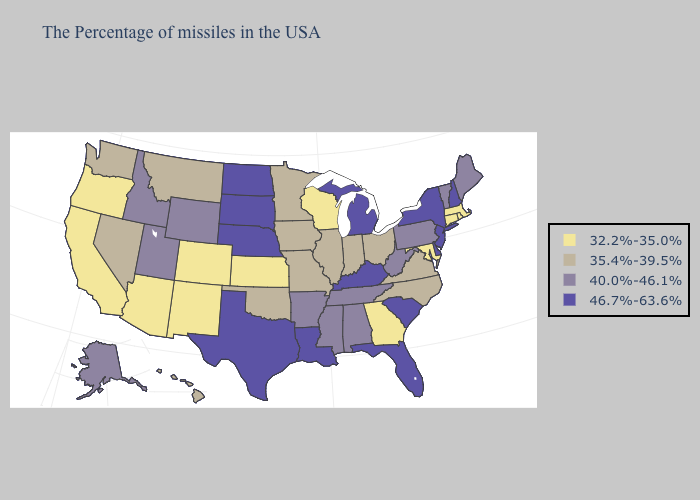What is the value of Pennsylvania?
Concise answer only. 40.0%-46.1%. What is the lowest value in states that border Maine?
Short answer required. 46.7%-63.6%. What is the highest value in states that border Colorado?
Short answer required. 46.7%-63.6%. Name the states that have a value in the range 46.7%-63.6%?
Give a very brief answer. New Hampshire, New York, New Jersey, Delaware, South Carolina, Florida, Michigan, Kentucky, Louisiana, Nebraska, Texas, South Dakota, North Dakota. What is the lowest value in the USA?
Answer briefly. 32.2%-35.0%. What is the value of Michigan?
Short answer required. 46.7%-63.6%. What is the highest value in the USA?
Write a very short answer. 46.7%-63.6%. What is the value of Maryland?
Quick response, please. 32.2%-35.0%. Which states have the lowest value in the USA?
Short answer required. Massachusetts, Rhode Island, Connecticut, Maryland, Georgia, Wisconsin, Kansas, Colorado, New Mexico, Arizona, California, Oregon. Which states have the highest value in the USA?
Write a very short answer. New Hampshire, New York, New Jersey, Delaware, South Carolina, Florida, Michigan, Kentucky, Louisiana, Nebraska, Texas, South Dakota, North Dakota. What is the lowest value in the USA?
Quick response, please. 32.2%-35.0%. Name the states that have a value in the range 40.0%-46.1%?
Quick response, please. Maine, Vermont, Pennsylvania, West Virginia, Alabama, Tennessee, Mississippi, Arkansas, Wyoming, Utah, Idaho, Alaska. Does the map have missing data?
Be succinct. No. What is the value of Massachusetts?
Keep it brief. 32.2%-35.0%. How many symbols are there in the legend?
Quick response, please. 4. 